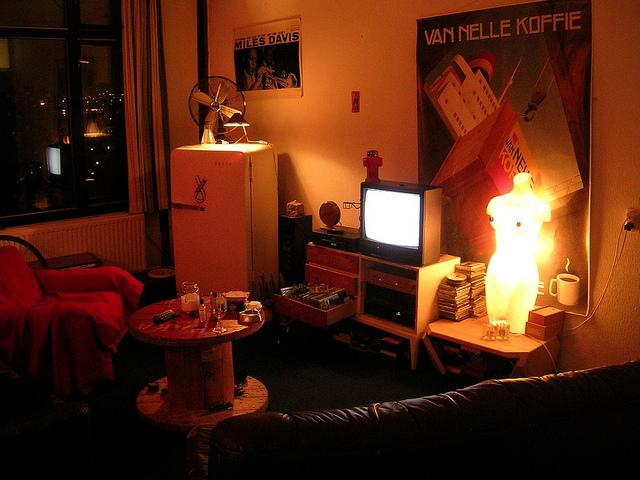Is the room dark lit?
Concise answer only. Yes. What form of light is on the tables?
Answer briefly. Lamp. Is that a new version refrigerator?
Give a very brief answer. No. What does the lamp look like?
Be succinct. Torso. 